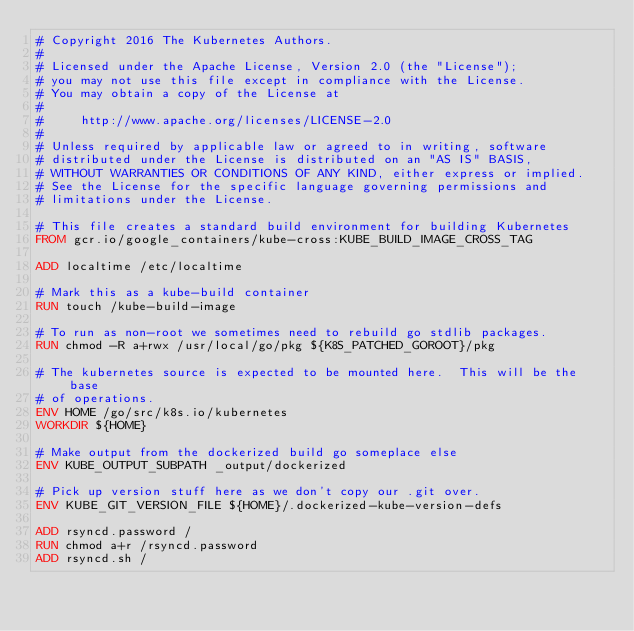<code> <loc_0><loc_0><loc_500><loc_500><_Dockerfile_># Copyright 2016 The Kubernetes Authors.
#
# Licensed under the Apache License, Version 2.0 (the "License");
# you may not use this file except in compliance with the License.
# You may obtain a copy of the License at
#
#     http://www.apache.org/licenses/LICENSE-2.0
#
# Unless required by applicable law or agreed to in writing, software
# distributed under the License is distributed on an "AS IS" BASIS,
# WITHOUT WARRANTIES OR CONDITIONS OF ANY KIND, either express or implied.
# See the License for the specific language governing permissions and
# limitations under the License.

# This file creates a standard build environment for building Kubernetes
FROM gcr.io/google_containers/kube-cross:KUBE_BUILD_IMAGE_CROSS_TAG

ADD localtime /etc/localtime

# Mark this as a kube-build container
RUN touch /kube-build-image

# To run as non-root we sometimes need to rebuild go stdlib packages.
RUN chmod -R a+rwx /usr/local/go/pkg ${K8S_PATCHED_GOROOT}/pkg

# The kubernetes source is expected to be mounted here.  This will be the base
# of operations.
ENV HOME /go/src/k8s.io/kubernetes
WORKDIR ${HOME}

# Make output from the dockerized build go someplace else
ENV KUBE_OUTPUT_SUBPATH _output/dockerized

# Pick up version stuff here as we don't copy our .git over.
ENV KUBE_GIT_VERSION_FILE ${HOME}/.dockerized-kube-version-defs

ADD rsyncd.password /
RUN chmod a+r /rsyncd.password
ADD rsyncd.sh /
</code> 